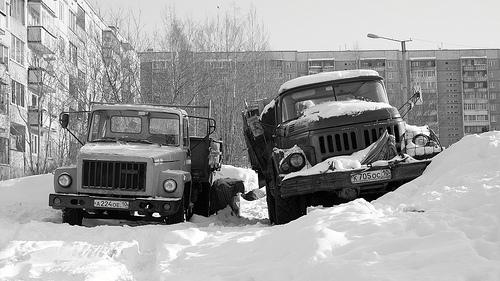Identify the main colors used in the image along with their associated elements. Main colors: White (snow-covered trucks and license plate), Black (black truck), Grey (concrete building), Brown (tree elements). List the main components in the image and the corresponding colors. White pickup truck, black pickup truck, snow mountain, tall concrete building, black and white license plate, side view mirror, bare trees, building balcony, street light. What is the weather condition exhibited in the image? The weather condition in the image appears to be cold and snowy. Mention the primary subject and its surroundings in the photograph. A tall concrete building with balconies is the primary subject, surrounded by parked trucks covered in snow, bare trees, and a street light. Enumerate the vehicles in the photo and describe their state of operation. Two old trucks, a white and a black one, both covered in snow and parked. Point out the natural elements present in the picture and state their current condition. The picture has bare trees without leaves and a pile of snow, indicating a wintery season. Describe the vehicular subjects in the image and their current state. Two old pickup trucks, one white and one black, are parked on the snow, both with snow on their hoods and roofs. Give a brief account of the buildings in the image and their construction features. The image features a tall concrete building with balconies and an apartment building, both with distinctive balcony features. Explain the state of the trees in the image and their impact on the overall scene. The trees in the image are bare of leaves, creating a wintery atmosphere and complementing the snow-covered trucks and ground. Provide a brief summary of the main elements in the picture. Two old trucks covered in snow are parked outside an apartment building with balconies, surrounded by leafless trees and a street light nearby. 